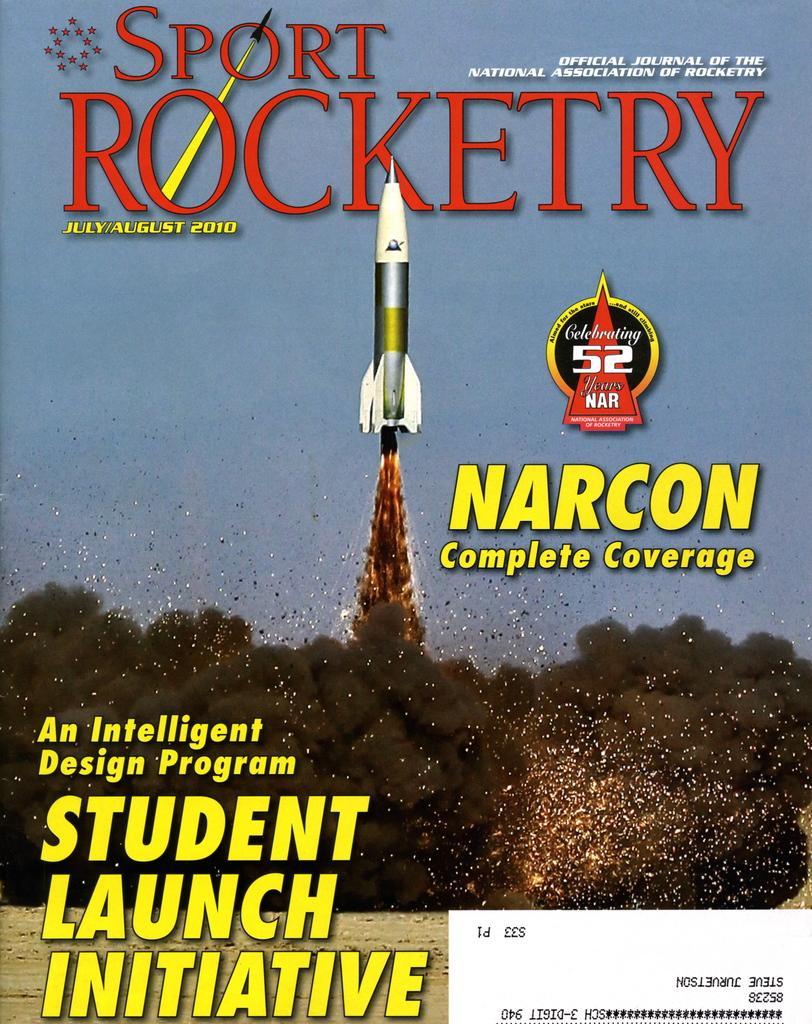Could you give a brief overview of what you see in this image? In this image I can see a depiction picture of a rocket and of smoke. I can also see something is written on the top, in the centre and on the bottom side of the image. 